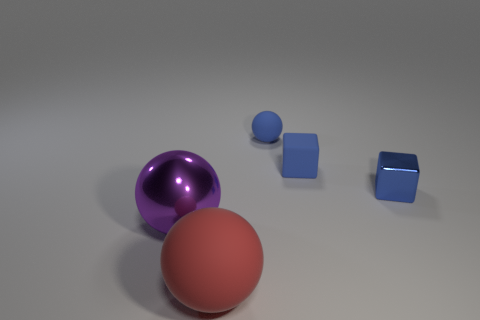Add 1 tiny blue blocks. How many objects exist? 6 Subtract 1 blocks. How many blocks are left? 1 Subtract all purple balls. Subtract all purple cylinders. How many balls are left? 2 Subtract all blue cubes. How many blue balls are left? 1 Subtract all tiny red cylinders. Subtract all large spheres. How many objects are left? 3 Add 4 matte blocks. How many matte blocks are left? 5 Add 2 rubber cubes. How many rubber cubes exist? 3 Subtract all purple balls. How many balls are left? 2 Subtract all red balls. How many balls are left? 2 Subtract 0 gray cylinders. How many objects are left? 5 